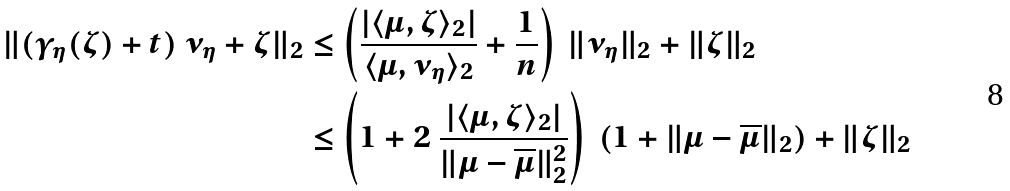<formula> <loc_0><loc_0><loc_500><loc_500>\| ( \gamma _ { \eta } ( \zeta ) + t ) \ \nu _ { \eta } + \zeta \| _ { 2 } & \leq \left ( \frac { | \langle \mu , \zeta \rangle _ { 2 } | } { \langle \mu , \nu _ { \eta } \rangle _ { 2 } } + \frac { 1 } { n } \right ) \ \| \nu _ { \eta } \| _ { 2 } + \| \zeta \| _ { 2 } \\ & \leq \left ( 1 + 2 \ \frac { | \langle \mu , \zeta \rangle _ { 2 } | } { \| \mu - \overline { \mu } \| _ { 2 } ^ { 2 } } \right ) \ ( 1 + \| \mu - \overline { \mu } \| _ { 2 } ) + \| \zeta \| _ { 2 }</formula> 